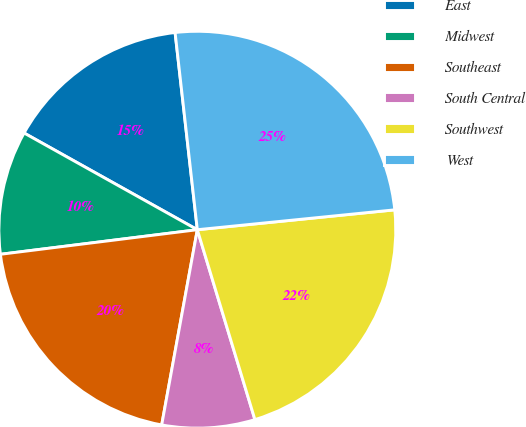Convert chart to OTSL. <chart><loc_0><loc_0><loc_500><loc_500><pie_chart><fcel>East<fcel>Midwest<fcel>Southeast<fcel>South Central<fcel>Southwest<fcel>West<nl><fcel>15.11%<fcel>10.08%<fcel>20.15%<fcel>7.56%<fcel>21.91%<fcel>25.19%<nl></chart> 